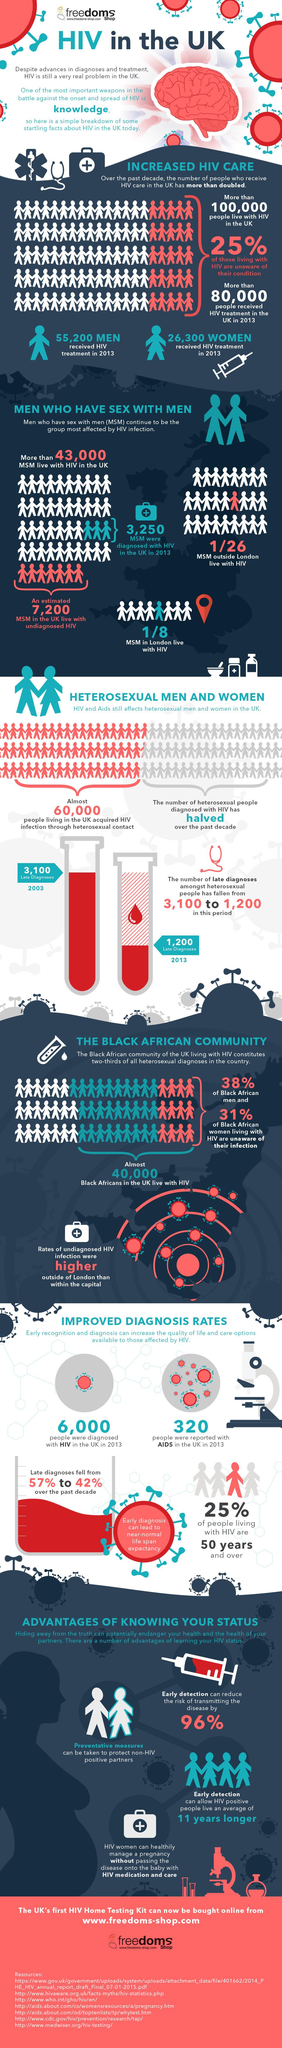Specify some key components in this picture. If a sample of 26 MSM (men who have sex with men) who are not from London is taken, then how many of them are not HIV positive? The answer is 25. In 2013, it was confirmed that 320 people in the United Kingdom were living with HIV/AIDS. The number of late diagnoses has been significantly reduced from 2003 to 2013, with a decrease of 1900. The percentage of people living with HIV who are not 50 years old is 75%. In the United Kingdom in 2013, approximately 6,000 people were confirmed to have HIV. 